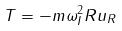<formula> <loc_0><loc_0><loc_500><loc_500>T = - m \omega _ { I } ^ { 2 } R u _ { R }</formula> 